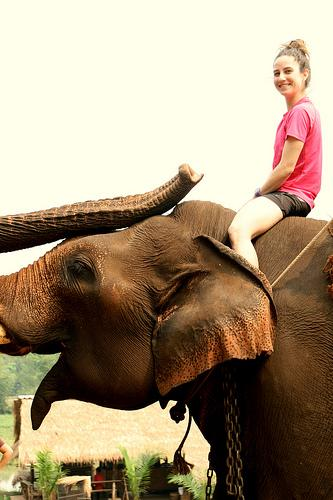Please provide a short summary of the scene in this image. A woman wearing a red shirt is sitting on an elephant, while a man stands nearby. There are white clouds in the blue sky and a building with a straw-covered roof in the background. Can you tell me what object is interacting with the elephant? There are chains hanging from the elephant, and a lady is sitting on top of the elephant. Identify and describe the side of the elephant's face that is visible. The left side of the elephant's face is visible, showing its ear, eye, and trunk. Count the number of people and the number of elephants in the image. There are 2 people and 1 elephant in the image. Does the image display any sort of emotions? If so, which one(s)? The image portrays a sense of happiness, as the girl is smiling while sitting on the elephant. What part of the woman's body is turned to the left? The girl's head is turned to the left. How many white clouds are there in the blue sky? There are 8 white clouds in the blue sky. Using complex reasoning, describe the possible relationship between the people and the elephant. The woman and the man may be tourists on a guided tour, participating in an elephant ride where the elephant is tamed and controlled by chains, indicating a human-animal interaction with potential ethical concerns. Describe two aspects related to the woman's physical features or fashion accessories. The woman is smiling and she is wearing a watch on her wrist. Analyze the quality of this image in terms of clarity and composition. The image has a well-defined composition with clear object details, making it easy to understand and interpret the contents. What object can be seen hanging from the elephant? Chains What is the large animal present in the image? Elephant Identify any significant event happening in the image involving the woman and the elephant. The woman is sitting on the elephant. Do you see the helicopter flying above the white clouds in the blue sky? No, it's not mentioned in the image. Zoom into the vivid red ball on the ground in the image. There are no objects mentioned in the image that could be described as a vivid red ball or any object on the ground, making this instruction misleading. Which emotion can be seen on the face of the girl in the image? Smiling How many trees can be seen in the background? One tree Is the woman wearing a watch? Yes Describe the woman's facial features. She has her forehead, eyes, nose, mouth, teeth, lips, and ear visible. What type of roof is on the building in the background? A roof covered in straw Identify any person next to the elephant and describe their position in relation to the animal. Someone is standing next to the elephant on the left side. Where is the purple bird sitting on the tree branch? The image actually contains an elephant, a woman, and clouds in the sky, but there is no mention of any bird or tree branch. How many clouds are present in the sky? Eight white clouds Does the woman have any accessories visible on her arm? Yes, she is wearing a watch. What gender is the person sitting on the elephant? Female Describe the main action taking place between the woman and the animal in the image. The woman is sitting on the elephant's back, and the elephant's trunk is on its head. Describe the setting in which the elephant and the woman are present. A lady is sitting on an elephant, with a tree and a building with a straw-covered roof in the background. What is the woman doing in the image? The woman is sitting on an elephant. What is the color of the lady's shirt? b. Blue Identify and describe the people near the elephant. A lady sitting on the elephant and someone standing next to it. Which part of the elephant is the woman sitting on? On its back 